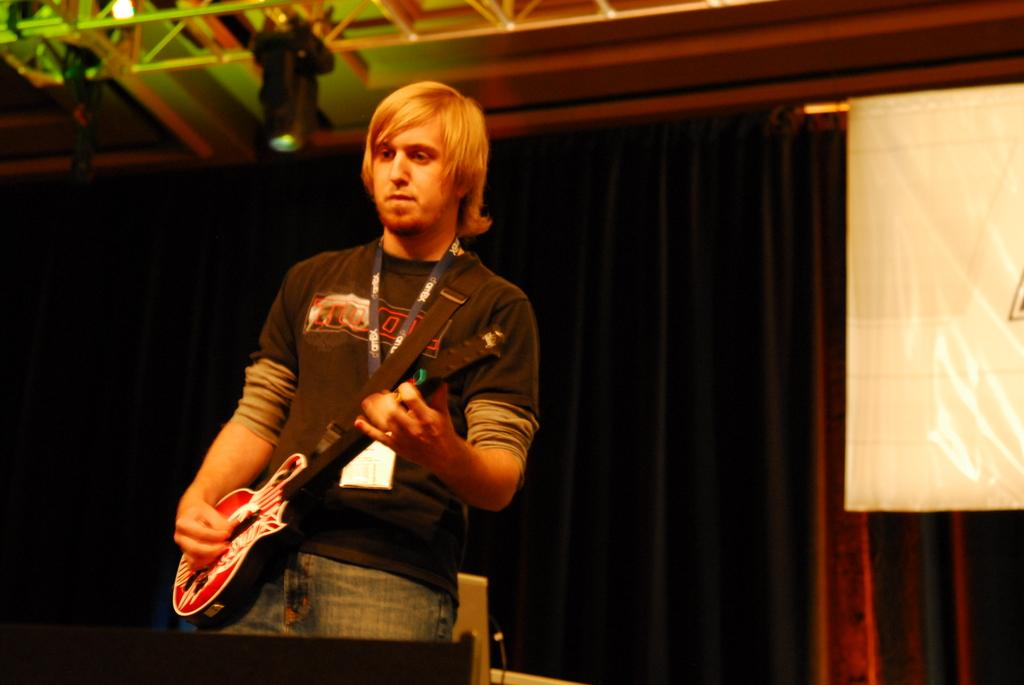Who is the person in the image? There is a man in the image. What is the man holding in the image? The man is holding a guitar. What is the man doing with the guitar? The man is playing the guitar. Can you describe any accessories the man is wearing? The man is wearing an ID card. What can be seen in the background of the image? There is a black curtain in the background. Where is the flag located in the image? The flag is visible at the middle of the right side of the image. What type of hat is the man wearing in the image? There is no hat visible in the image; the man is wearing an ID card. How many quinces are present in the image? There are no quinces present in the image. 